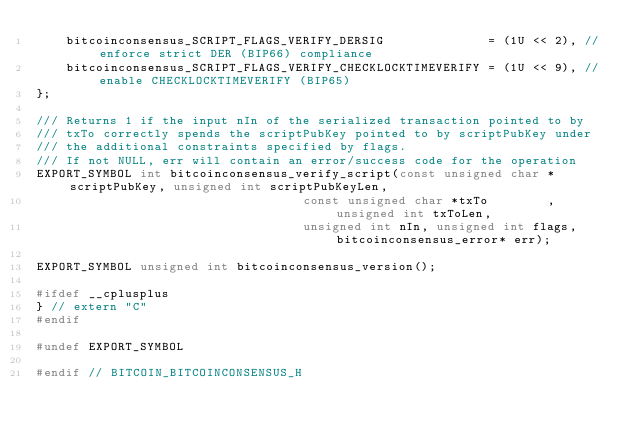Convert code to text. <code><loc_0><loc_0><loc_500><loc_500><_C_>    bitcoinconsensus_SCRIPT_FLAGS_VERIFY_DERSIG              = (1U << 2), // enforce strict DER (BIP66) compliance
    bitcoinconsensus_SCRIPT_FLAGS_VERIFY_CHECKLOCKTIMEVERIFY = (1U << 9), // enable CHECKLOCKTIMEVERIFY (BIP65)
};

/// Returns 1 if the input nIn of the serialized transaction pointed to by
/// txTo correctly spends the scriptPubKey pointed to by scriptPubKey under
/// the additional constraints specified by flags.
/// If not NULL, err will contain an error/success code for the operation
EXPORT_SYMBOL int bitcoinconsensus_verify_script(const unsigned char *scriptPubKey, unsigned int scriptPubKeyLen,
                                    const unsigned char *txTo        , unsigned int txToLen,
                                    unsigned int nIn, unsigned int flags, bitcoinconsensus_error* err);

EXPORT_SYMBOL unsigned int bitcoinconsensus_version();

#ifdef __cplusplus
} // extern "C"
#endif

#undef EXPORT_SYMBOL

#endif // BITCOIN_BITCOINCONSENSUS_H
</code> 